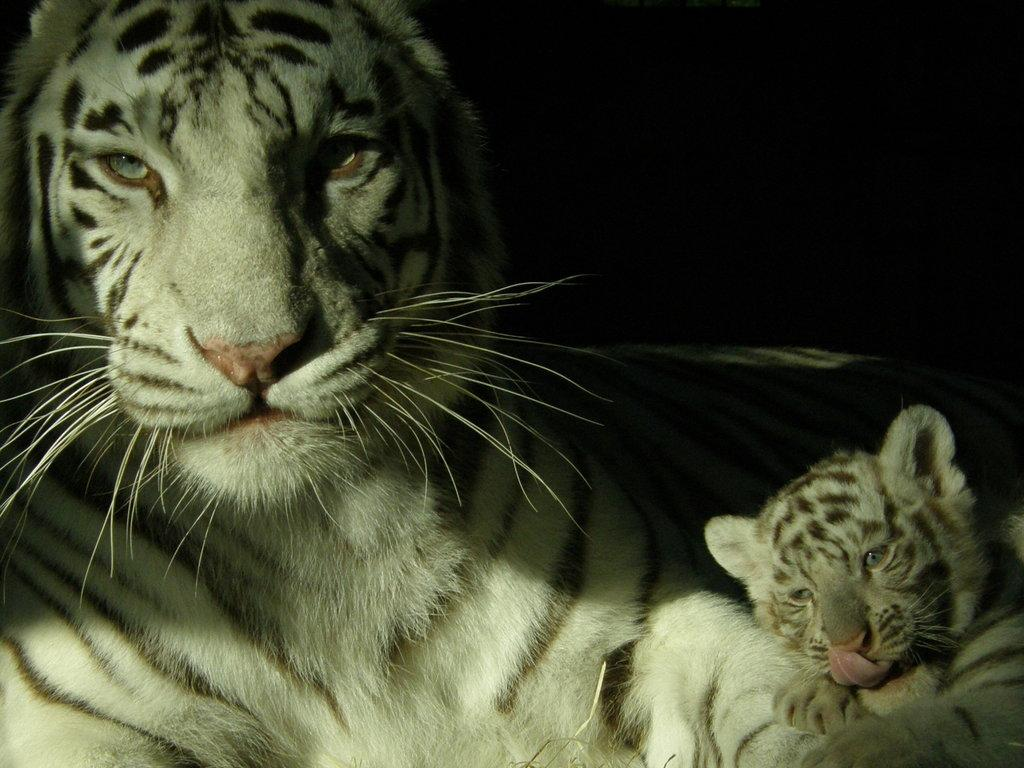How many animals are present in the image? There are two animals in the image. What can be observed about the background of the image? The background of the image is dark. What type of hand can be seen holding the boat in the image? There is no hand or boat present in the image; it only features two animals. Is there a boy visible in the image? No, there is no boy present in the image; it only features two animals. 